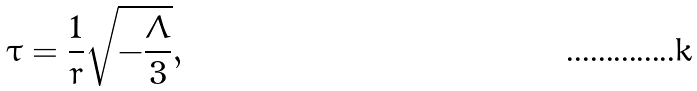<formula> <loc_0><loc_0><loc_500><loc_500>\tau = \frac { 1 } { r } { \sqrt { - \frac { \Lambda } { 3 } } } ,</formula> 